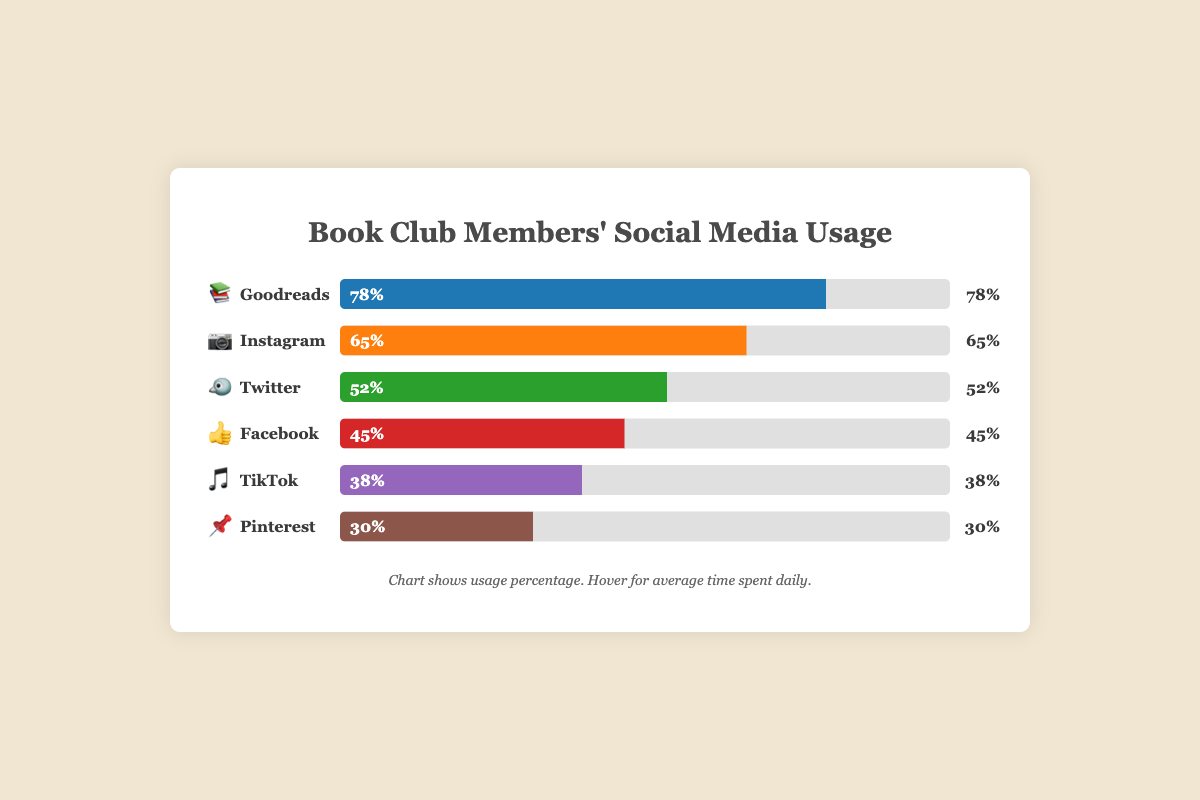What's the most popular social media platform among book club members? The chart presents usage percentages for six social media platforms used by book club members. Verify which platform has the highest percentage. The platform with the highest usage is Goodreads at 78%.
Answer: Goodreads Which platform has the lowest usage percentage among book club members? The chart shows usage percentages for six different platforms. Identify the platform with the lowest percentage, which is Pinterest with 30%.
Answer: Pinterest What's the average time spent daily on Instagram by book club members? By hovering over the Instagram bar in the chart, you see that the average time spent on Instagram is 30 minutes per day.
Answer: 30 minutes How much more usage percentage does Goodreads have compared to Facebook? Goodreads has a usage percentage of 78% and Facebook has 45%. Subtract Facebook's percentage from Goodreads' to find the difference: 78% - 45% = 33%.
Answer: 33% How much time do book club members spend on Twitter daily? By hovering over the Twitter bar in the chart, you find the average time spent on Twitter is 25 minutes per day.
Answer: 25 minutes Which platform do book club members spend the least amount of time on daily? Hover over the bars to see the average time spent on each platform. TikTok, with 15 minutes per day, has the lowest average.
Answer: TikTok Between Instagram and TikTok, which platform has a higher percentage of use among book club members? Compare the usage percentages of Instagram (65%) and TikTok (38%) to see that Instagram has a higher percentage than TikTok.
Answer: Instagram If you add the usage percentages of Pinterest and TikTok, what do you get? Pinterest has a usage percentage of 30%, and TikTok has 38%. Adding these percentages together gives: 30% + 38% = 68%.
Answer: 68% How much greater is the average time spent on Goodreads compared to Pinterest? Goodreads has an average time spent of 45 minutes, while Pinterest has 18 minutes. Subtract the smaller value from the larger: 45 - 18 = 27 minutes.
Answer: 27 minutes Which platform shows a 52% usage percentage, and how much time is spent on it daily? The chart indicates that Twitter has a usage percentage of 52%. Hovering over the Twitter bar shows that the average daily time spent is 25 minutes.
Answer: Twitter, 25 minutes 